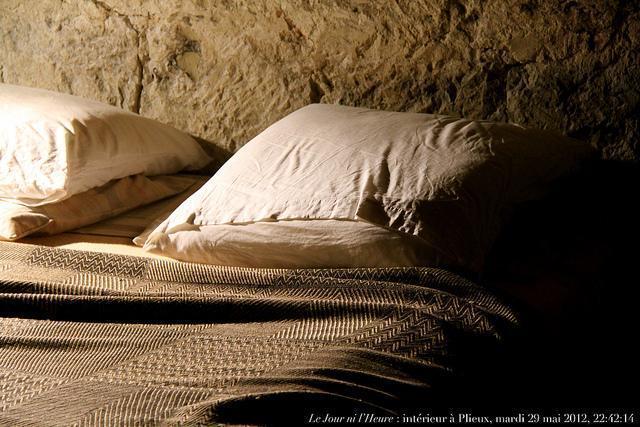How many beds are there?
Give a very brief answer. 1. 